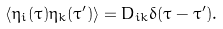<formula> <loc_0><loc_0><loc_500><loc_500>\left \langle \eta _ { i } ( \tau ) \eta _ { k } ( \tau ^ { \prime } ) \right \rangle = D _ { i k } \delta ( \tau - \tau ^ { \prime } ) .</formula> 